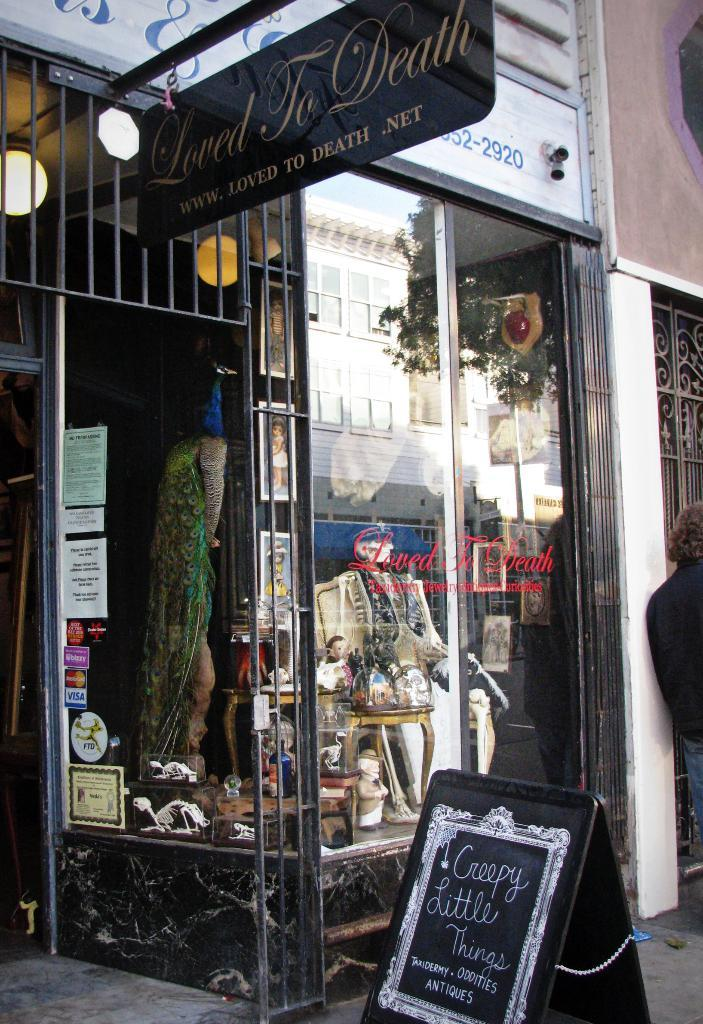What type of material is used for the boards in the image? The facts provided do not specify the material of the boards. What can be seen through the glass windows in the image? The glass windows allow for the visibility of many objects. What type of lighting is present in the image? There are ceiling lights in the image. Can you describe the person standing in the image? The facts provided do not describe the person's appearance or actions. What is the history of the owner of the boards in the image? There is no information about the owner of the boards in the image, nor is there any mention of history. 